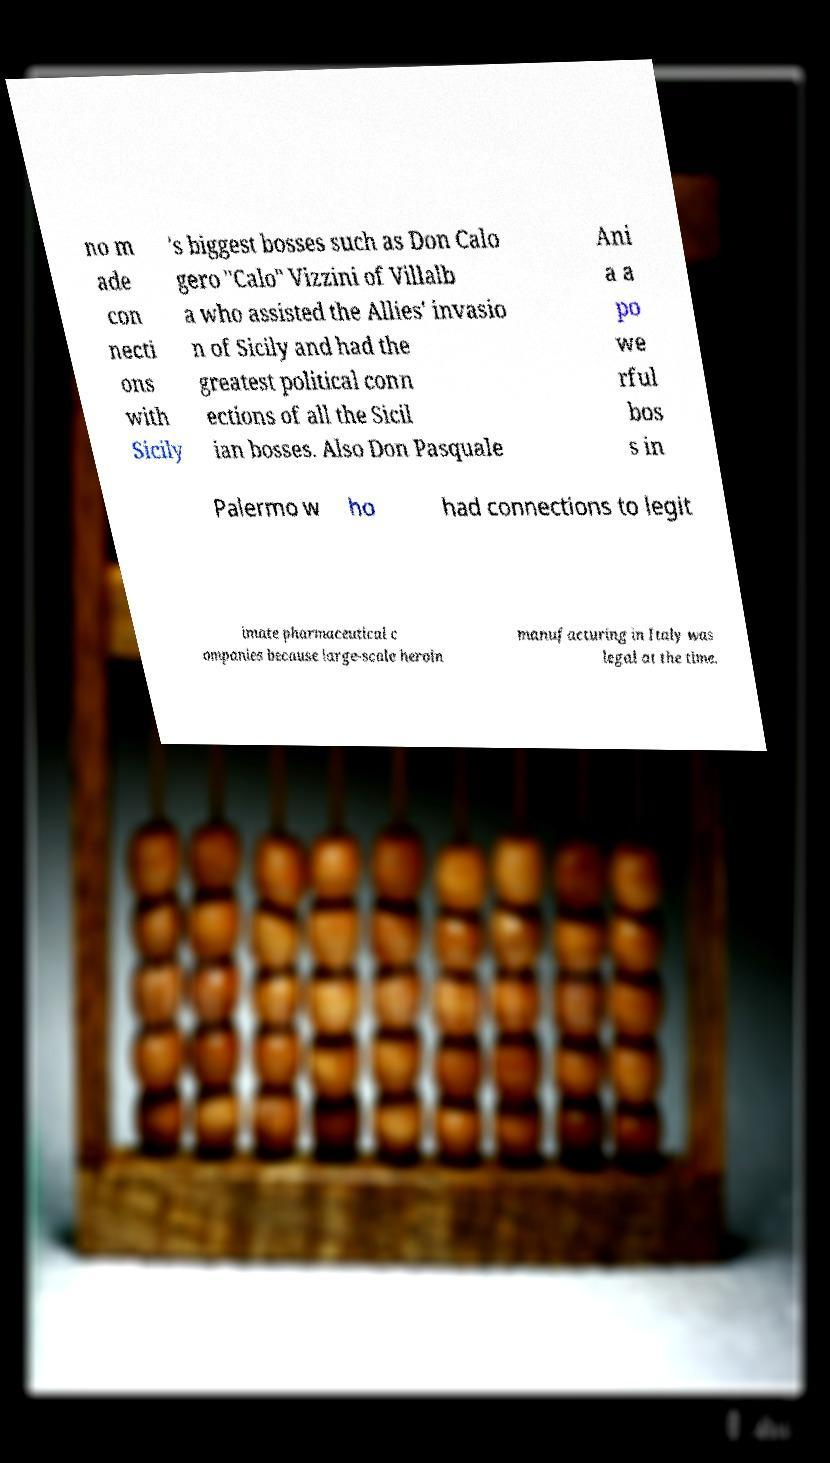Please identify and transcribe the text found in this image. no m ade con necti ons with Sicily 's biggest bosses such as Don Calo gero "Calo" Vizzini of Villalb a who assisted the Allies' invasio n of Sicily and had the greatest political conn ections of all the Sicil ian bosses. Also Don Pasquale Ani a a po we rful bos s in Palermo w ho had connections to legit imate pharmaceutical c ompanies because large-scale heroin manufacturing in Italy was legal at the time. 